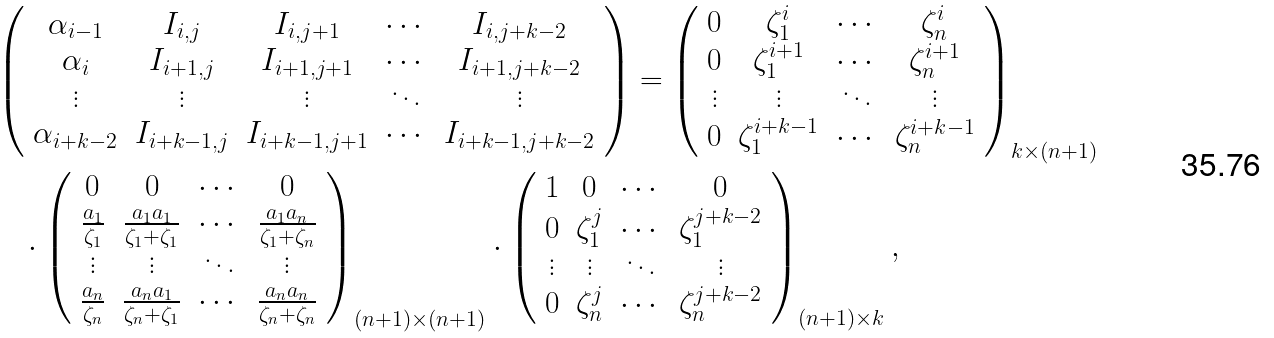Convert formula to latex. <formula><loc_0><loc_0><loc_500><loc_500>& \left ( \begin{array} { c c c c c } \alpha _ { i - 1 } & I _ { i , j } & I _ { i , j + 1 } & \cdots & I _ { i , j + k - 2 } \\ \alpha _ { i } & I _ { i + 1 , j } & I _ { i + 1 , j + 1 } & \cdots & I _ { i + 1 , j + k - 2 } \\ \vdots & \vdots & \vdots & \ddots & \vdots \\ \alpha _ { i + k - 2 } & I _ { i + k - 1 , j } & I _ { i + k - 1 , j + 1 } & \cdots & I _ { i + k - 1 , j + k - 2 } \end{array} \right ) = \left ( \begin{array} { c c c c } 0 & \zeta _ { 1 } ^ { i } & \cdots & \zeta _ { n } ^ { i } \\ 0 & \zeta _ { 1 } ^ { i + 1 } & \cdots & \zeta _ { n } ^ { i + 1 } \\ \vdots & \vdots & \ddots & \vdots \\ 0 & \zeta _ { 1 } ^ { i + k - 1 } & \cdots & \zeta _ { n } ^ { i + k - 1 } \end{array} \right ) _ { k \times ( n + 1 ) } \\ & \quad \cdot \left ( \begin{array} { c c c c } 0 & 0 & \cdots & 0 \\ \frac { a _ { 1 } } { \zeta _ { 1 } } & \frac { a _ { 1 } a _ { 1 } } { \zeta _ { 1 } + \zeta _ { 1 } } & \cdots & \frac { a _ { 1 } a _ { n } } { \zeta _ { 1 } + \zeta _ { n } } \\ \vdots & \vdots & \ddots & \vdots \\ \frac { a _ { n } } { \zeta _ { n } } & \frac { a _ { n } a _ { 1 } } { \zeta _ { n } + \zeta _ { 1 } } & \cdots & \frac { a _ { n } a _ { n } } { \zeta _ { n } + \zeta _ { n } } \end{array} \right ) _ { ( n + 1 ) \times ( n + 1 ) } \cdot \left ( \begin{array} { c c c c } 1 & 0 & \cdots & 0 \\ 0 & \zeta _ { 1 } ^ { j } & \cdots & \zeta _ { 1 } ^ { j + k - 2 } \\ \vdots & \vdots & \ddots & \vdots \\ 0 & \zeta _ { n } ^ { j } & \cdots & \zeta _ { n } ^ { j + k - 2 } \end{array} \right ) _ { ( n + 1 ) \times k } ,</formula> 